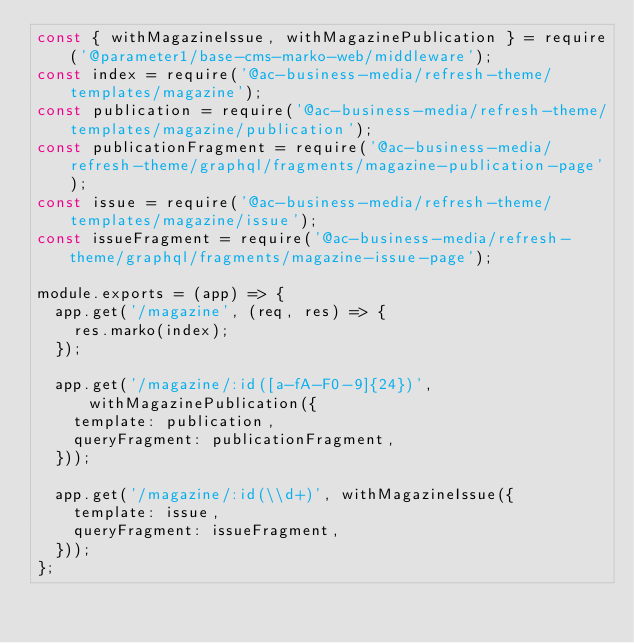Convert code to text. <code><loc_0><loc_0><loc_500><loc_500><_JavaScript_>const { withMagazineIssue, withMagazinePublication } = require('@parameter1/base-cms-marko-web/middleware');
const index = require('@ac-business-media/refresh-theme/templates/magazine');
const publication = require('@ac-business-media/refresh-theme/templates/magazine/publication');
const publicationFragment = require('@ac-business-media/refresh-theme/graphql/fragments/magazine-publication-page');
const issue = require('@ac-business-media/refresh-theme/templates/magazine/issue');
const issueFragment = require('@ac-business-media/refresh-theme/graphql/fragments/magazine-issue-page');

module.exports = (app) => {
  app.get('/magazine', (req, res) => {
    res.marko(index);
  });

  app.get('/magazine/:id([a-fA-F0-9]{24})', withMagazinePublication({
    template: publication,
    queryFragment: publicationFragment,
  }));

  app.get('/magazine/:id(\\d+)', withMagazineIssue({
    template: issue,
    queryFragment: issueFragment,
  }));
};
</code> 